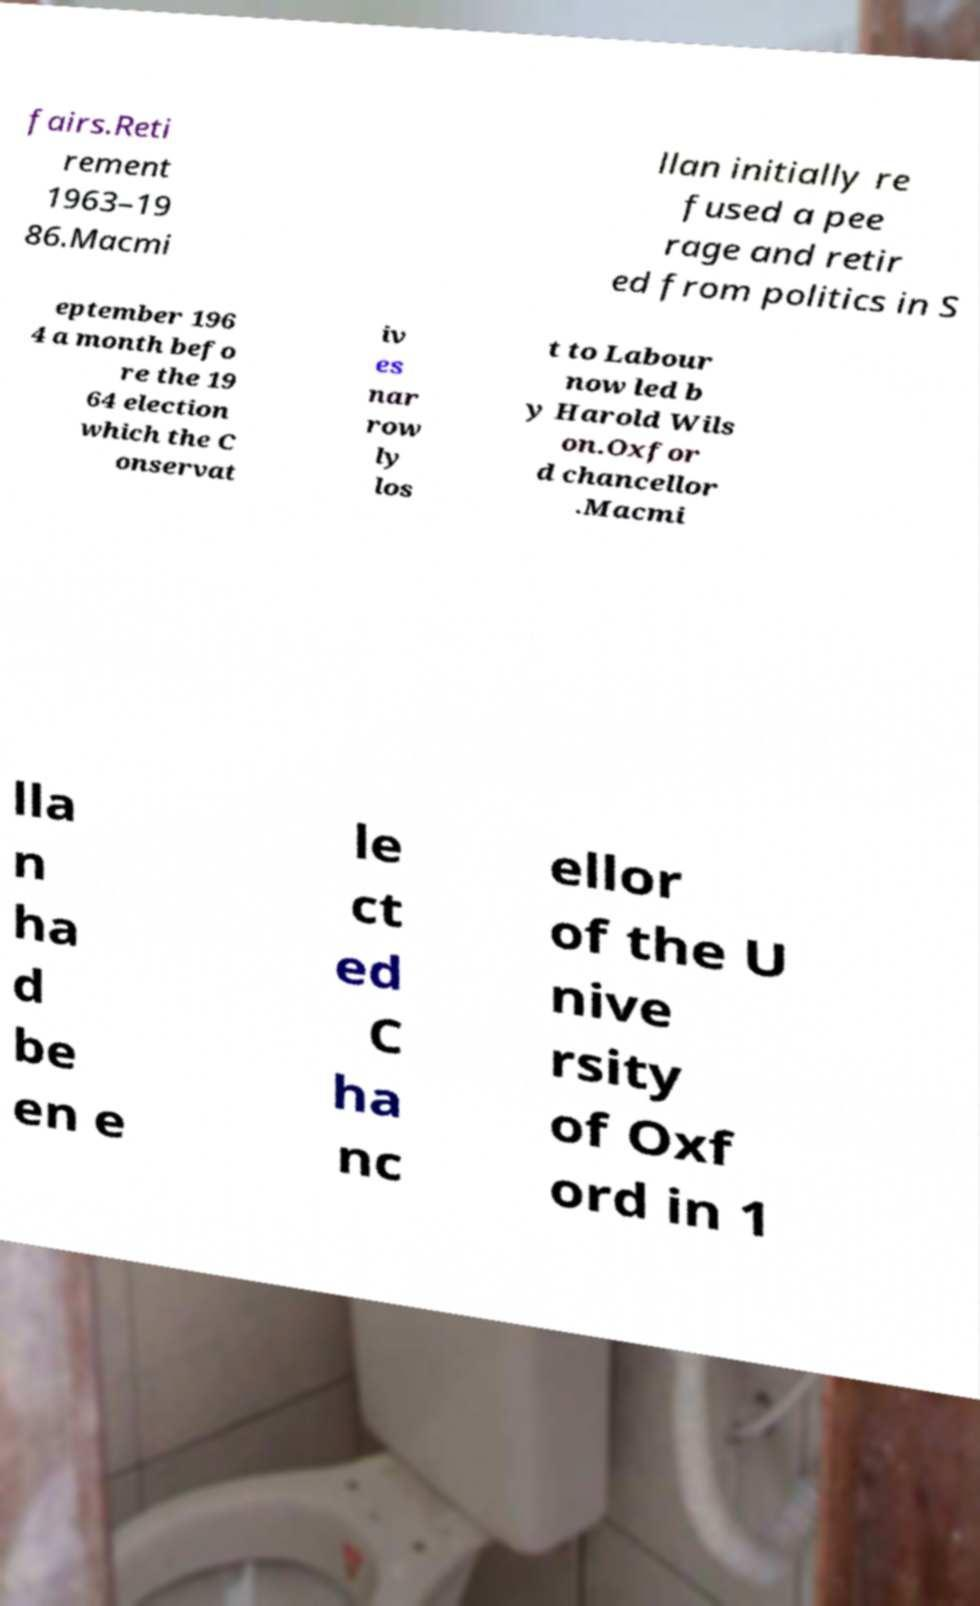Please identify and transcribe the text found in this image. fairs.Reti rement 1963–19 86.Macmi llan initially re fused a pee rage and retir ed from politics in S eptember 196 4 a month befo re the 19 64 election which the C onservat iv es nar row ly los t to Labour now led b y Harold Wils on.Oxfor d chancellor .Macmi lla n ha d be en e le ct ed C ha nc ellor of the U nive rsity of Oxf ord in 1 